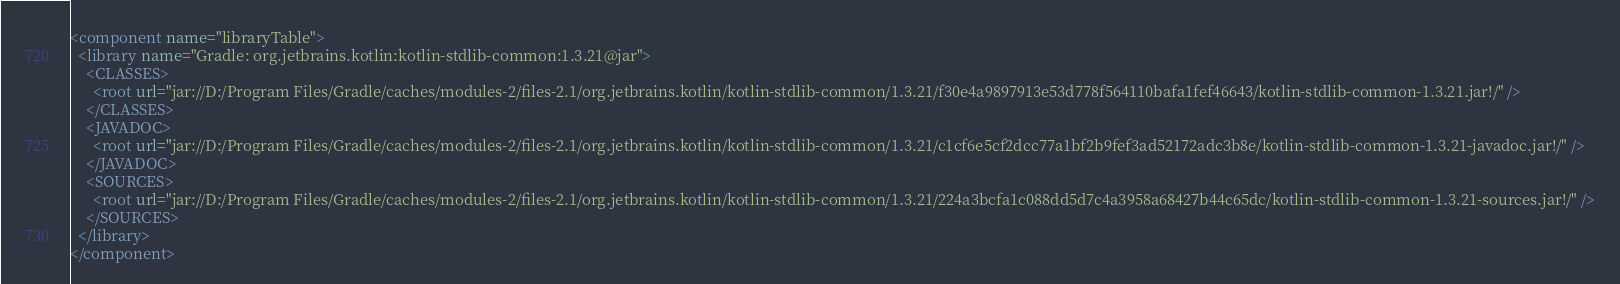Convert code to text. <code><loc_0><loc_0><loc_500><loc_500><_XML_><component name="libraryTable">
  <library name="Gradle: org.jetbrains.kotlin:kotlin-stdlib-common:1.3.21@jar">
    <CLASSES>
      <root url="jar://D:/Program Files/Gradle/caches/modules-2/files-2.1/org.jetbrains.kotlin/kotlin-stdlib-common/1.3.21/f30e4a9897913e53d778f564110bafa1fef46643/kotlin-stdlib-common-1.3.21.jar!/" />
    </CLASSES>
    <JAVADOC>
      <root url="jar://D:/Program Files/Gradle/caches/modules-2/files-2.1/org.jetbrains.kotlin/kotlin-stdlib-common/1.3.21/c1cf6e5cf2dcc77a1bf2b9fef3ad52172adc3b8e/kotlin-stdlib-common-1.3.21-javadoc.jar!/" />
    </JAVADOC>
    <SOURCES>
      <root url="jar://D:/Program Files/Gradle/caches/modules-2/files-2.1/org.jetbrains.kotlin/kotlin-stdlib-common/1.3.21/224a3bcfa1c088dd5d7c4a3958a68427b44c65dc/kotlin-stdlib-common-1.3.21-sources.jar!/" />
    </SOURCES>
  </library>
</component></code> 